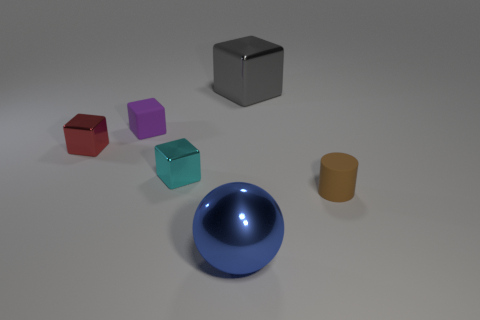There is a cyan object to the left of the brown matte object; is its size the same as the gray cube?
Offer a terse response. No. What is the size of the matte thing that is the same shape as the tiny red metal thing?
Your answer should be compact. Small. There is a brown thing that is the same size as the purple rubber object; what is its material?
Ensure brevity in your answer.  Rubber. There is a cyan object that is the same shape as the tiny red metallic object; what material is it?
Offer a terse response. Metal. How many other things are the same size as the sphere?
Your answer should be very brief. 1. How many big metallic balls have the same color as the cylinder?
Your answer should be compact. 0. What shape is the big gray object?
Provide a succinct answer. Cube. There is a metallic cube that is to the right of the tiny rubber cube and in front of the big gray object; what color is it?
Give a very brief answer. Cyan. What is the big gray object made of?
Your answer should be compact. Metal. What is the shape of the matte thing that is to the right of the blue metallic sphere?
Your answer should be compact. Cylinder. 